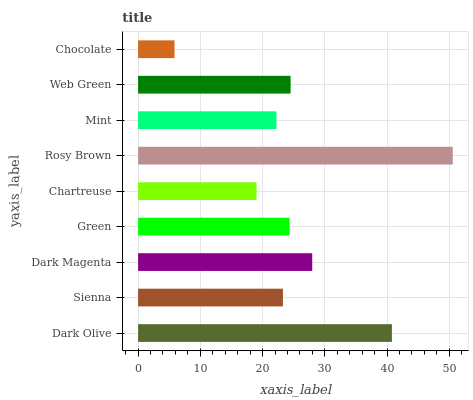Is Chocolate the minimum?
Answer yes or no. Yes. Is Rosy Brown the maximum?
Answer yes or no. Yes. Is Sienna the minimum?
Answer yes or no. No. Is Sienna the maximum?
Answer yes or no. No. Is Dark Olive greater than Sienna?
Answer yes or no. Yes. Is Sienna less than Dark Olive?
Answer yes or no. Yes. Is Sienna greater than Dark Olive?
Answer yes or no. No. Is Dark Olive less than Sienna?
Answer yes or no. No. Is Green the high median?
Answer yes or no. Yes. Is Green the low median?
Answer yes or no. Yes. Is Web Green the high median?
Answer yes or no. No. Is Sienna the low median?
Answer yes or no. No. 